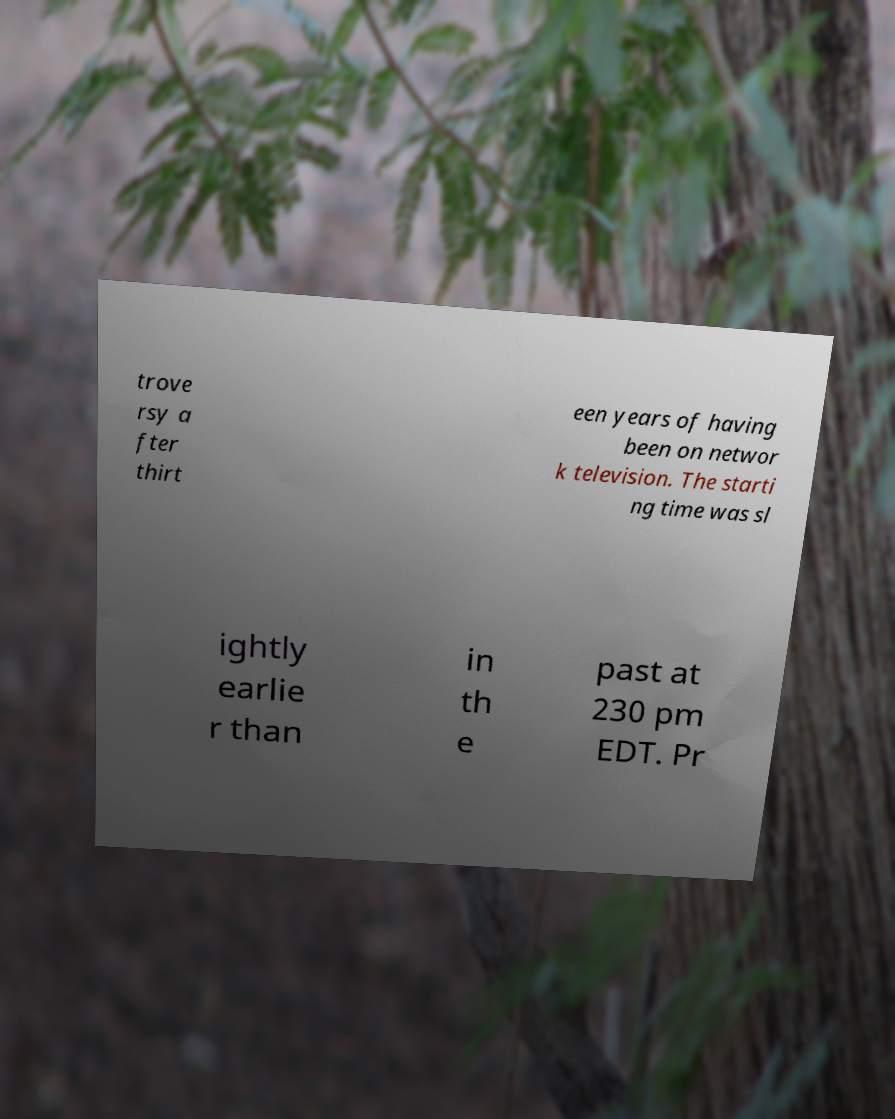Could you assist in decoding the text presented in this image and type it out clearly? trove rsy a fter thirt een years of having been on networ k television. The starti ng time was sl ightly earlie r than in th e past at 230 pm EDT. Pr 